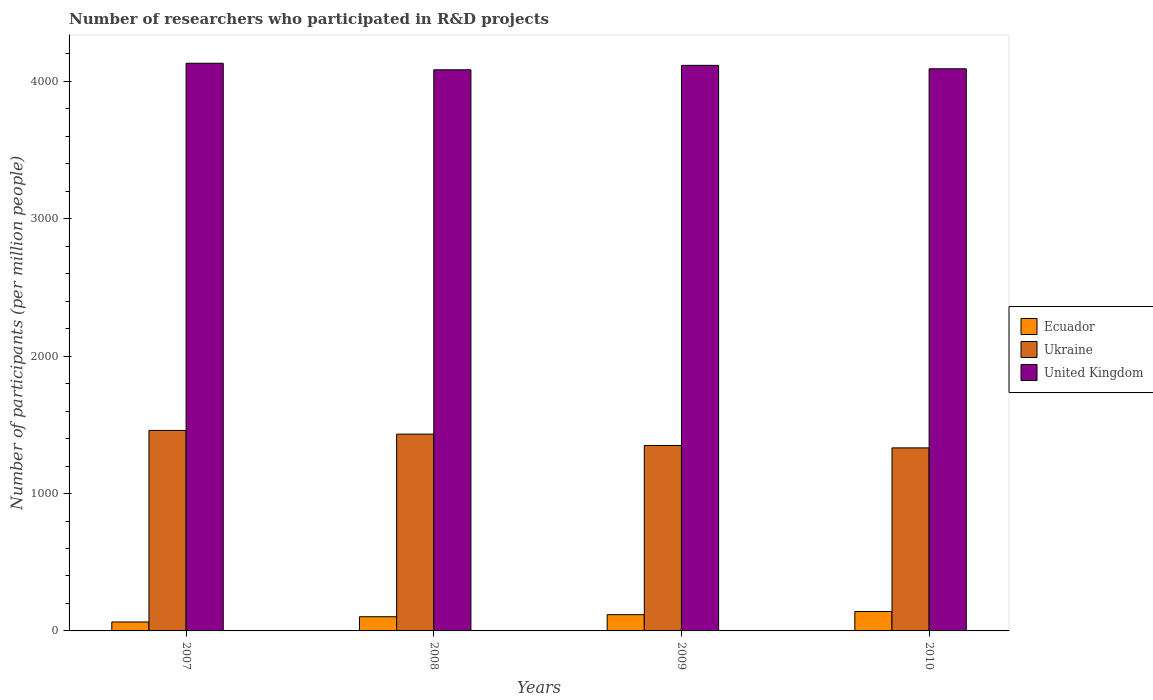Are the number of bars on each tick of the X-axis equal?
Your answer should be compact. Yes. How many bars are there on the 1st tick from the left?
Your answer should be very brief. 3. What is the label of the 3rd group of bars from the left?
Make the answer very short. 2009. What is the number of researchers who participated in R&D projects in Ecuador in 2007?
Ensure brevity in your answer.  65.05. Across all years, what is the maximum number of researchers who participated in R&D projects in Ukraine?
Offer a very short reply. 1459.32. Across all years, what is the minimum number of researchers who participated in R&D projects in United Kingdom?
Provide a succinct answer. 4083.86. In which year was the number of researchers who participated in R&D projects in Ukraine maximum?
Provide a succinct answer. 2007. In which year was the number of researchers who participated in R&D projects in Ecuador minimum?
Make the answer very short. 2007. What is the total number of researchers who participated in R&D projects in Ecuador in the graph?
Offer a terse response. 427.93. What is the difference between the number of researchers who participated in R&D projects in United Kingdom in 2009 and that in 2010?
Your answer should be compact. 25.17. What is the difference between the number of researchers who participated in R&D projects in Ukraine in 2010 and the number of researchers who participated in R&D projects in United Kingdom in 2009?
Provide a short and direct response. -2784.15. What is the average number of researchers who participated in R&D projects in United Kingdom per year?
Provide a succinct answer. 4105.73. In the year 2010, what is the difference between the number of researchers who participated in R&D projects in Ecuador and number of researchers who participated in R&D projects in Ukraine?
Provide a short and direct response. -1190.9. What is the ratio of the number of researchers who participated in R&D projects in Ecuador in 2007 to that in 2009?
Provide a succinct answer. 0.55. Is the number of researchers who participated in R&D projects in Ukraine in 2008 less than that in 2010?
Keep it short and to the point. No. Is the difference between the number of researchers who participated in R&D projects in Ecuador in 2007 and 2008 greater than the difference between the number of researchers who participated in R&D projects in Ukraine in 2007 and 2008?
Offer a terse response. No. What is the difference between the highest and the second highest number of researchers who participated in R&D projects in United Kingdom?
Your response must be concise. 15.18. What is the difference between the highest and the lowest number of researchers who participated in R&D projects in Ecuador?
Keep it short and to the point. 76.25. In how many years, is the number of researchers who participated in R&D projects in Ecuador greater than the average number of researchers who participated in R&D projects in Ecuador taken over all years?
Offer a very short reply. 2. Is the sum of the number of researchers who participated in R&D projects in Ukraine in 2008 and 2010 greater than the maximum number of researchers who participated in R&D projects in Ecuador across all years?
Your answer should be compact. Yes. What does the 3rd bar from the left in 2009 represents?
Provide a short and direct response. United Kingdom. What does the 2nd bar from the right in 2010 represents?
Your answer should be very brief. Ukraine. Is it the case that in every year, the sum of the number of researchers who participated in R&D projects in Ukraine and number of researchers who participated in R&D projects in United Kingdom is greater than the number of researchers who participated in R&D projects in Ecuador?
Provide a succinct answer. Yes. Does the graph contain grids?
Give a very brief answer. No. How many legend labels are there?
Your response must be concise. 3. What is the title of the graph?
Keep it short and to the point. Number of researchers who participated in R&D projects. Does "Ethiopia" appear as one of the legend labels in the graph?
Provide a short and direct response. No. What is the label or title of the X-axis?
Provide a short and direct response. Years. What is the label or title of the Y-axis?
Offer a very short reply. Number of participants (per million people). What is the Number of participants (per million people) of Ecuador in 2007?
Provide a short and direct response. 65.05. What is the Number of participants (per million people) of Ukraine in 2007?
Make the answer very short. 1459.32. What is the Number of participants (per million people) of United Kingdom in 2007?
Make the answer very short. 4131.53. What is the Number of participants (per million people) of Ecuador in 2008?
Offer a terse response. 103.23. What is the Number of participants (per million people) of Ukraine in 2008?
Make the answer very short. 1432.33. What is the Number of participants (per million people) in United Kingdom in 2008?
Offer a terse response. 4083.86. What is the Number of participants (per million people) in Ecuador in 2009?
Your answer should be very brief. 118.35. What is the Number of participants (per million people) in Ukraine in 2009?
Your answer should be compact. 1349.71. What is the Number of participants (per million people) of United Kingdom in 2009?
Give a very brief answer. 4116.35. What is the Number of participants (per million people) in Ecuador in 2010?
Ensure brevity in your answer.  141.3. What is the Number of participants (per million people) of Ukraine in 2010?
Your answer should be very brief. 1332.2. What is the Number of participants (per million people) of United Kingdom in 2010?
Ensure brevity in your answer.  4091.18. Across all years, what is the maximum Number of participants (per million people) of Ecuador?
Give a very brief answer. 141.3. Across all years, what is the maximum Number of participants (per million people) in Ukraine?
Offer a terse response. 1459.32. Across all years, what is the maximum Number of participants (per million people) in United Kingdom?
Keep it short and to the point. 4131.53. Across all years, what is the minimum Number of participants (per million people) in Ecuador?
Offer a terse response. 65.05. Across all years, what is the minimum Number of participants (per million people) in Ukraine?
Your answer should be compact. 1332.2. Across all years, what is the minimum Number of participants (per million people) of United Kingdom?
Your answer should be very brief. 4083.86. What is the total Number of participants (per million people) of Ecuador in the graph?
Offer a terse response. 427.93. What is the total Number of participants (per million people) of Ukraine in the graph?
Give a very brief answer. 5573.56. What is the total Number of participants (per million people) in United Kingdom in the graph?
Ensure brevity in your answer.  1.64e+04. What is the difference between the Number of participants (per million people) of Ecuador in 2007 and that in 2008?
Offer a terse response. -38.19. What is the difference between the Number of participants (per million people) of Ukraine in 2007 and that in 2008?
Your answer should be very brief. 26.99. What is the difference between the Number of participants (per million people) of United Kingdom in 2007 and that in 2008?
Give a very brief answer. 47.67. What is the difference between the Number of participants (per million people) in Ecuador in 2007 and that in 2009?
Your answer should be very brief. -53.3. What is the difference between the Number of participants (per million people) of Ukraine in 2007 and that in 2009?
Your answer should be very brief. 109.61. What is the difference between the Number of participants (per million people) in United Kingdom in 2007 and that in 2009?
Your answer should be very brief. 15.18. What is the difference between the Number of participants (per million people) in Ecuador in 2007 and that in 2010?
Offer a very short reply. -76.25. What is the difference between the Number of participants (per million people) of Ukraine in 2007 and that in 2010?
Offer a very short reply. 127.12. What is the difference between the Number of participants (per million people) of United Kingdom in 2007 and that in 2010?
Offer a terse response. 40.36. What is the difference between the Number of participants (per million people) of Ecuador in 2008 and that in 2009?
Offer a terse response. -15.12. What is the difference between the Number of participants (per million people) of Ukraine in 2008 and that in 2009?
Provide a succinct answer. 82.62. What is the difference between the Number of participants (per million people) of United Kingdom in 2008 and that in 2009?
Keep it short and to the point. -32.49. What is the difference between the Number of participants (per million people) in Ecuador in 2008 and that in 2010?
Your answer should be compact. -38.07. What is the difference between the Number of participants (per million people) of Ukraine in 2008 and that in 2010?
Provide a succinct answer. 100.13. What is the difference between the Number of participants (per million people) of United Kingdom in 2008 and that in 2010?
Ensure brevity in your answer.  -7.32. What is the difference between the Number of participants (per million people) in Ecuador in 2009 and that in 2010?
Your answer should be compact. -22.95. What is the difference between the Number of participants (per million people) of Ukraine in 2009 and that in 2010?
Make the answer very short. 17.51. What is the difference between the Number of participants (per million people) in United Kingdom in 2009 and that in 2010?
Provide a succinct answer. 25.17. What is the difference between the Number of participants (per million people) in Ecuador in 2007 and the Number of participants (per million people) in Ukraine in 2008?
Your answer should be compact. -1367.28. What is the difference between the Number of participants (per million people) in Ecuador in 2007 and the Number of participants (per million people) in United Kingdom in 2008?
Keep it short and to the point. -4018.81. What is the difference between the Number of participants (per million people) of Ukraine in 2007 and the Number of participants (per million people) of United Kingdom in 2008?
Your response must be concise. -2624.54. What is the difference between the Number of participants (per million people) in Ecuador in 2007 and the Number of participants (per million people) in Ukraine in 2009?
Your response must be concise. -1284.67. What is the difference between the Number of participants (per million people) in Ecuador in 2007 and the Number of participants (per million people) in United Kingdom in 2009?
Provide a succinct answer. -4051.31. What is the difference between the Number of participants (per million people) in Ukraine in 2007 and the Number of participants (per million people) in United Kingdom in 2009?
Offer a terse response. -2657.03. What is the difference between the Number of participants (per million people) in Ecuador in 2007 and the Number of participants (per million people) in Ukraine in 2010?
Give a very brief answer. -1267.15. What is the difference between the Number of participants (per million people) of Ecuador in 2007 and the Number of participants (per million people) of United Kingdom in 2010?
Make the answer very short. -4026.13. What is the difference between the Number of participants (per million people) of Ukraine in 2007 and the Number of participants (per million people) of United Kingdom in 2010?
Offer a terse response. -2631.85. What is the difference between the Number of participants (per million people) in Ecuador in 2008 and the Number of participants (per million people) in Ukraine in 2009?
Your response must be concise. -1246.48. What is the difference between the Number of participants (per million people) of Ecuador in 2008 and the Number of participants (per million people) of United Kingdom in 2009?
Give a very brief answer. -4013.12. What is the difference between the Number of participants (per million people) of Ukraine in 2008 and the Number of participants (per million people) of United Kingdom in 2009?
Give a very brief answer. -2684.02. What is the difference between the Number of participants (per million people) of Ecuador in 2008 and the Number of participants (per million people) of Ukraine in 2010?
Your answer should be very brief. -1228.96. What is the difference between the Number of participants (per million people) in Ecuador in 2008 and the Number of participants (per million people) in United Kingdom in 2010?
Ensure brevity in your answer.  -3987.94. What is the difference between the Number of participants (per million people) of Ukraine in 2008 and the Number of participants (per million people) of United Kingdom in 2010?
Make the answer very short. -2658.85. What is the difference between the Number of participants (per million people) in Ecuador in 2009 and the Number of participants (per million people) in Ukraine in 2010?
Give a very brief answer. -1213.85. What is the difference between the Number of participants (per million people) in Ecuador in 2009 and the Number of participants (per million people) in United Kingdom in 2010?
Your response must be concise. -3972.83. What is the difference between the Number of participants (per million people) in Ukraine in 2009 and the Number of participants (per million people) in United Kingdom in 2010?
Give a very brief answer. -2741.46. What is the average Number of participants (per million people) in Ecuador per year?
Your answer should be compact. 106.98. What is the average Number of participants (per million people) in Ukraine per year?
Provide a short and direct response. 1393.39. What is the average Number of participants (per million people) of United Kingdom per year?
Provide a short and direct response. 4105.73. In the year 2007, what is the difference between the Number of participants (per million people) in Ecuador and Number of participants (per million people) in Ukraine?
Ensure brevity in your answer.  -1394.28. In the year 2007, what is the difference between the Number of participants (per million people) in Ecuador and Number of participants (per million people) in United Kingdom?
Make the answer very short. -4066.49. In the year 2007, what is the difference between the Number of participants (per million people) in Ukraine and Number of participants (per million people) in United Kingdom?
Your answer should be compact. -2672.21. In the year 2008, what is the difference between the Number of participants (per million people) in Ecuador and Number of participants (per million people) in Ukraine?
Your answer should be compact. -1329.1. In the year 2008, what is the difference between the Number of participants (per million people) of Ecuador and Number of participants (per million people) of United Kingdom?
Offer a very short reply. -3980.63. In the year 2008, what is the difference between the Number of participants (per million people) in Ukraine and Number of participants (per million people) in United Kingdom?
Keep it short and to the point. -2651.53. In the year 2009, what is the difference between the Number of participants (per million people) in Ecuador and Number of participants (per million people) in Ukraine?
Ensure brevity in your answer.  -1231.36. In the year 2009, what is the difference between the Number of participants (per million people) in Ecuador and Number of participants (per million people) in United Kingdom?
Ensure brevity in your answer.  -3998. In the year 2009, what is the difference between the Number of participants (per million people) of Ukraine and Number of participants (per million people) of United Kingdom?
Provide a short and direct response. -2766.64. In the year 2010, what is the difference between the Number of participants (per million people) in Ecuador and Number of participants (per million people) in Ukraine?
Your answer should be compact. -1190.9. In the year 2010, what is the difference between the Number of participants (per million people) in Ecuador and Number of participants (per million people) in United Kingdom?
Offer a terse response. -3949.88. In the year 2010, what is the difference between the Number of participants (per million people) of Ukraine and Number of participants (per million people) of United Kingdom?
Make the answer very short. -2758.98. What is the ratio of the Number of participants (per million people) of Ecuador in 2007 to that in 2008?
Offer a terse response. 0.63. What is the ratio of the Number of participants (per million people) of Ukraine in 2007 to that in 2008?
Keep it short and to the point. 1.02. What is the ratio of the Number of participants (per million people) in United Kingdom in 2007 to that in 2008?
Your response must be concise. 1.01. What is the ratio of the Number of participants (per million people) of Ecuador in 2007 to that in 2009?
Ensure brevity in your answer.  0.55. What is the ratio of the Number of participants (per million people) of Ukraine in 2007 to that in 2009?
Keep it short and to the point. 1.08. What is the ratio of the Number of participants (per million people) in Ecuador in 2007 to that in 2010?
Provide a short and direct response. 0.46. What is the ratio of the Number of participants (per million people) of Ukraine in 2007 to that in 2010?
Offer a very short reply. 1.1. What is the ratio of the Number of participants (per million people) of United Kingdom in 2007 to that in 2010?
Your answer should be very brief. 1.01. What is the ratio of the Number of participants (per million people) in Ecuador in 2008 to that in 2009?
Keep it short and to the point. 0.87. What is the ratio of the Number of participants (per million people) of Ukraine in 2008 to that in 2009?
Offer a very short reply. 1.06. What is the ratio of the Number of participants (per million people) in Ecuador in 2008 to that in 2010?
Your answer should be compact. 0.73. What is the ratio of the Number of participants (per million people) in Ukraine in 2008 to that in 2010?
Provide a succinct answer. 1.08. What is the ratio of the Number of participants (per million people) of Ecuador in 2009 to that in 2010?
Your response must be concise. 0.84. What is the ratio of the Number of participants (per million people) of Ukraine in 2009 to that in 2010?
Offer a terse response. 1.01. What is the ratio of the Number of participants (per million people) in United Kingdom in 2009 to that in 2010?
Your answer should be compact. 1.01. What is the difference between the highest and the second highest Number of participants (per million people) of Ecuador?
Provide a succinct answer. 22.95. What is the difference between the highest and the second highest Number of participants (per million people) of Ukraine?
Offer a very short reply. 26.99. What is the difference between the highest and the second highest Number of participants (per million people) of United Kingdom?
Ensure brevity in your answer.  15.18. What is the difference between the highest and the lowest Number of participants (per million people) in Ecuador?
Give a very brief answer. 76.25. What is the difference between the highest and the lowest Number of participants (per million people) in Ukraine?
Provide a succinct answer. 127.12. What is the difference between the highest and the lowest Number of participants (per million people) of United Kingdom?
Your response must be concise. 47.67. 